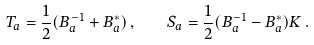<formula> <loc_0><loc_0><loc_500><loc_500>T _ { a } = \frac { 1 } { 2 } ( B _ { a } ^ { - 1 } + B _ { a } ^ { * } ) \, , \quad S _ { a } = \frac { 1 } { 2 } ( B _ { a } ^ { - 1 } - B _ { a } ^ { * } ) K \, .</formula> 